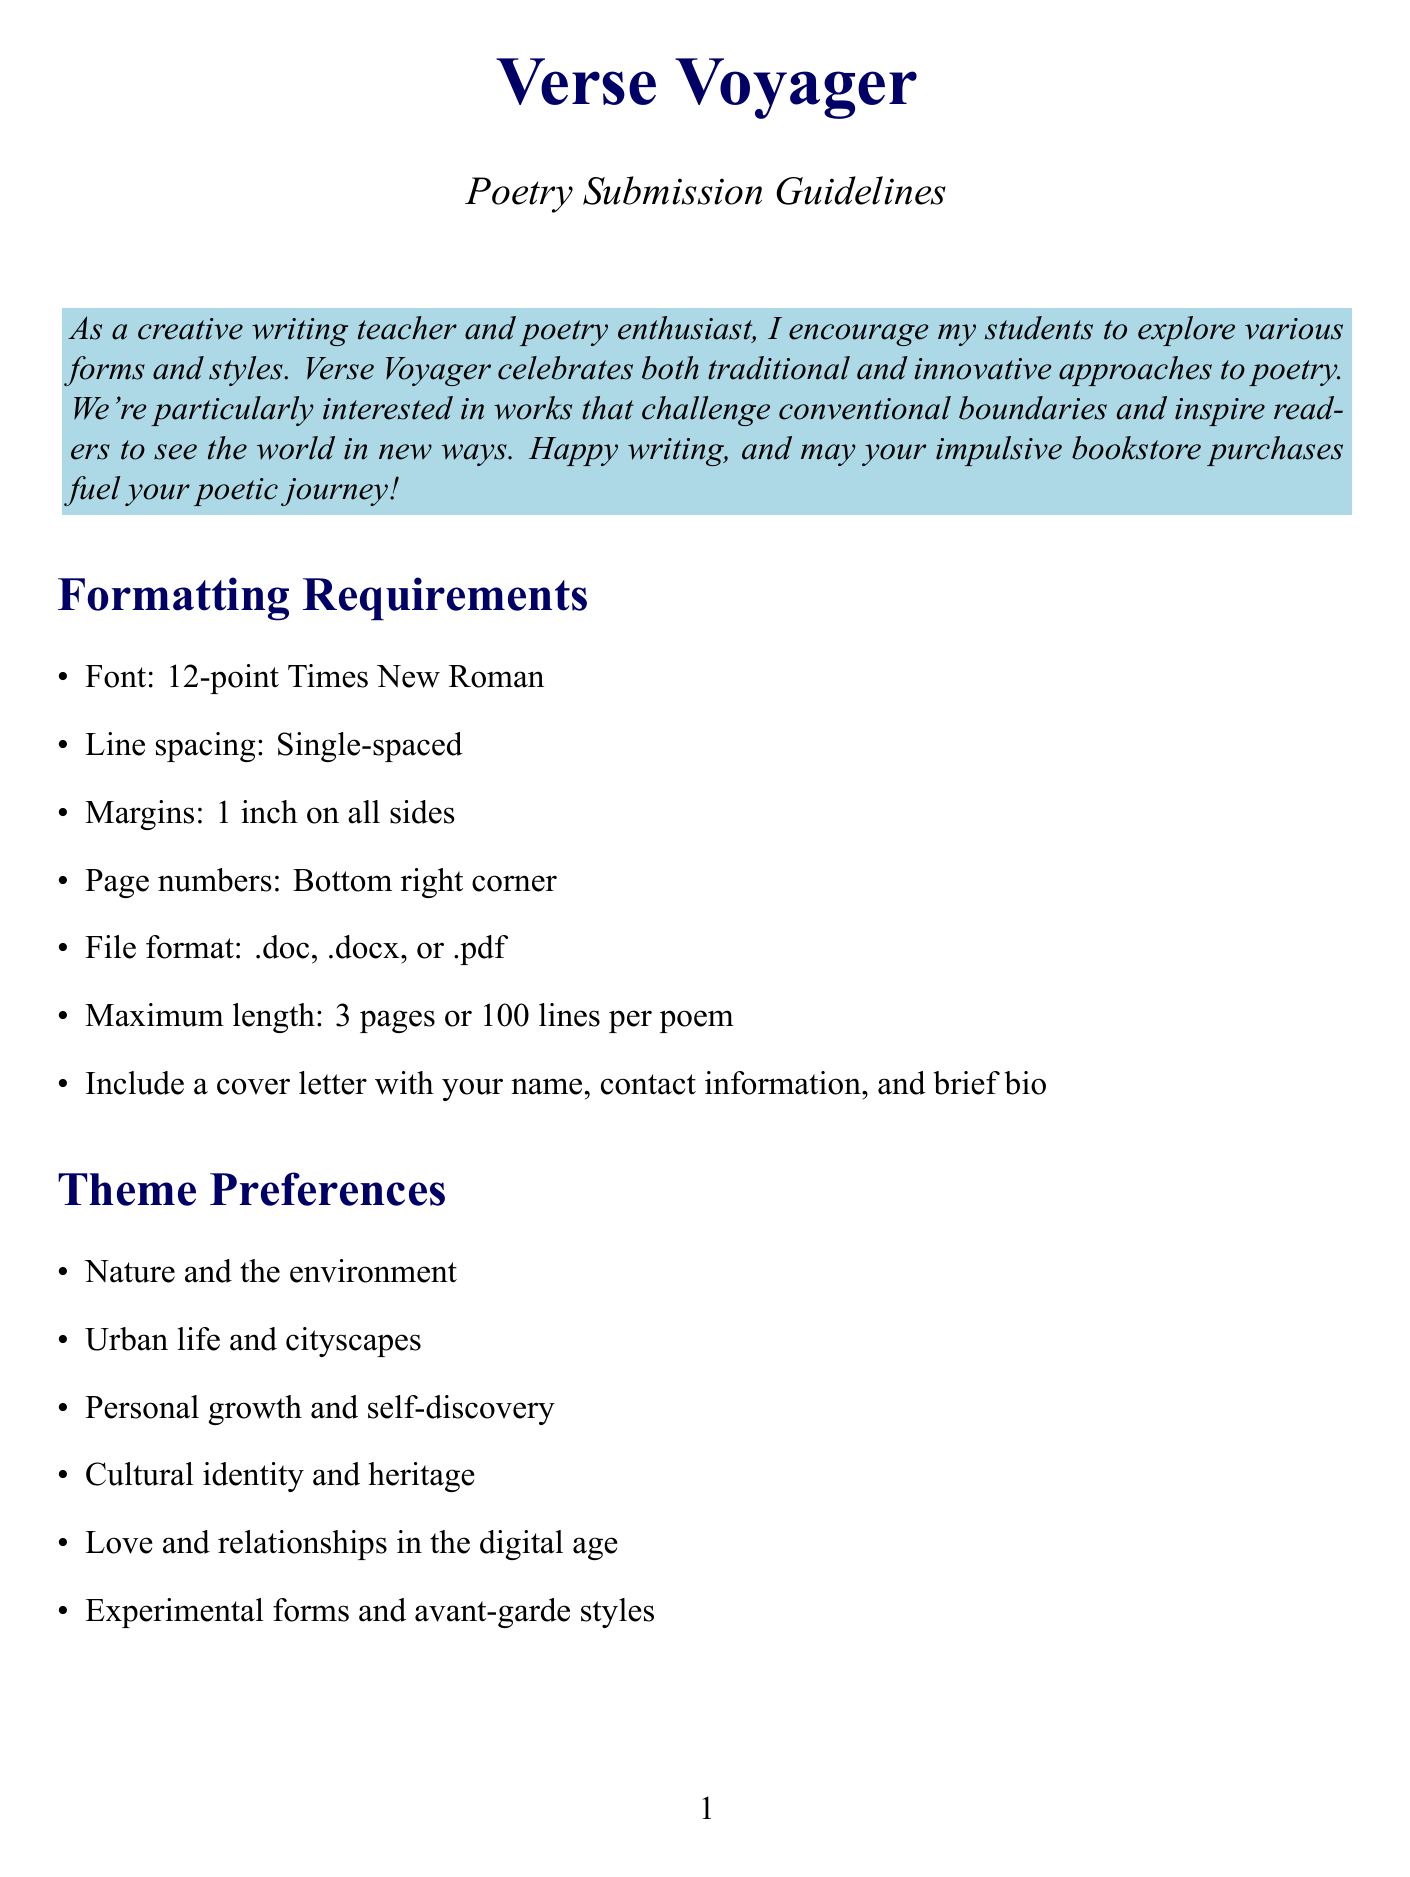What is the magazine name? The document starts with the title, which states the name of the magazine.
Answer: Verse Voyager What is the maximum length of a poem submission? The guidelines specify the maximum number of pages or lines for poems, indicating the length limit for submissions.
Answer: 3 pages or 100 lines What is the response time for submissions? The section on the submission process outlines the expected time it takes for authors to receive feedback after submission.
Answer: 8-12 weeks During which period is the Spring issue open for submissions? The submission periods section lists the dates when submissions for different seasonal issues are accepted.
Answer: September 1 - November 30 What is the payment for an accepted poem? The submission process details the compensation provided to poets whose work is accepted for publication.
Answer: 50 dollars What content is prohibited in submissions? The additional requirements section lists specific criteria that submissions must adhere to, including content restrictions.
Answer: No offensive or explicit content How many poems can be submitted at once? The submission process specifies the maximum number of poems allowed per submission.
Answer: 3 poems What type of rights does the magazine acquire upon publication? The additional requirements section outlines the rights arrangement between the author and the magazine upon acceptance.
Answer: First North American serial rights 